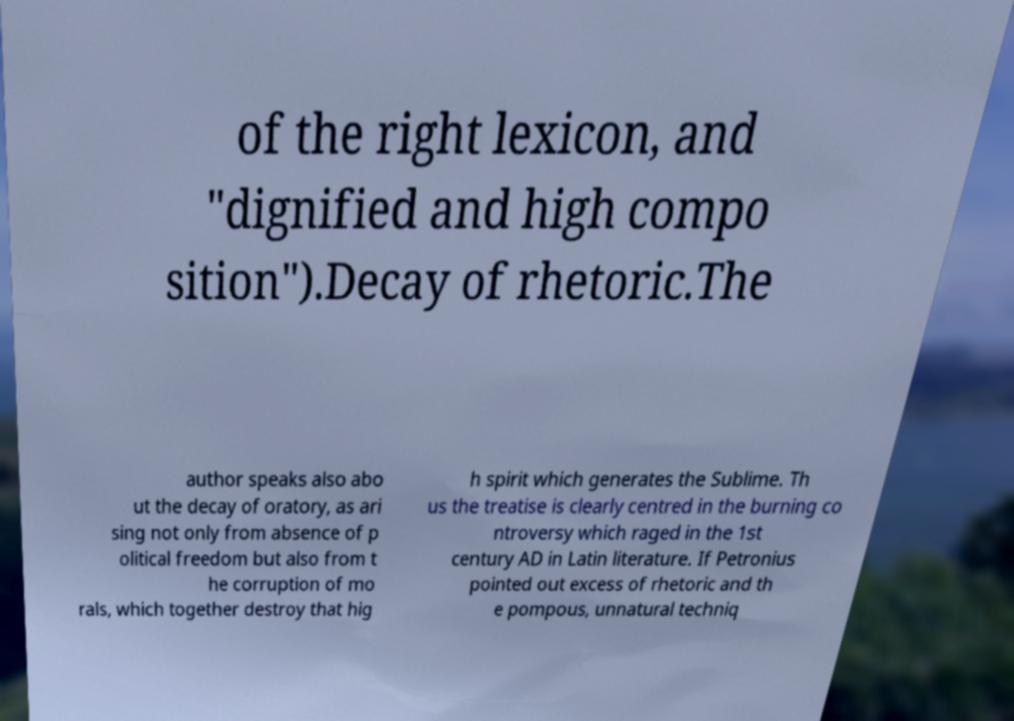There's text embedded in this image that I need extracted. Can you transcribe it verbatim? of the right lexicon, and "dignified and high compo sition").Decay of rhetoric.The author speaks also abo ut the decay of oratory, as ari sing not only from absence of p olitical freedom but also from t he corruption of mo rals, which together destroy that hig h spirit which generates the Sublime. Th us the treatise is clearly centred in the burning co ntroversy which raged in the 1st century AD in Latin literature. If Petronius pointed out excess of rhetoric and th e pompous, unnatural techniq 